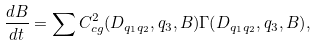Convert formula to latex. <formula><loc_0><loc_0><loc_500><loc_500>\frac { d B } { d t } = \sum { C _ { c g } ^ { 2 } ( D _ { q _ { 1 } q _ { 2 } } , q _ { 3 } , B ) \Gamma ( D _ { q _ { 1 } q _ { 2 } } , q _ { 3 } , B ) } ,</formula> 